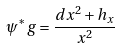<formula> <loc_0><loc_0><loc_500><loc_500>\psi ^ { * } g = \frac { d x ^ { 2 } + h _ { x } } { x ^ { 2 } }</formula> 